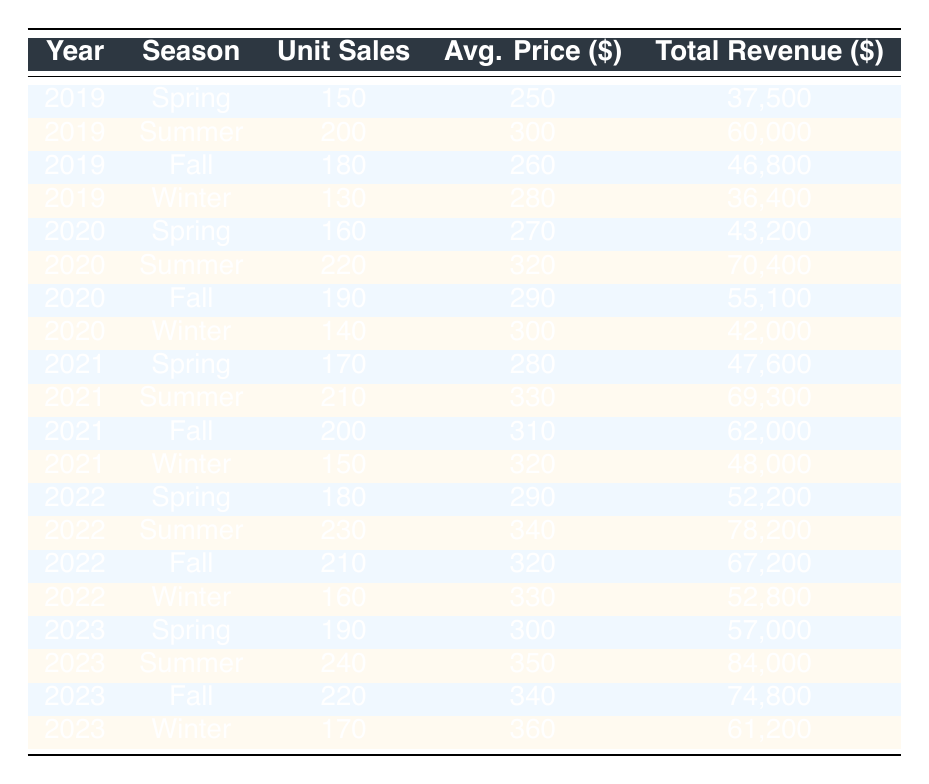What were the total unit sales of telescopes in Summer 2022? The table shows that in Summer 2022, the unit sales were recorded as 230.
Answer: 230 Which season had the highest total revenue in 2023? In 2023, the season with the highest total revenue was Summer, which reported a revenue of 84,000.
Answer: Summer How much did unit sales increase from Spring to Summer in 2021? The unit sales in Spring 2021 were 170 and in Summer 2021 were 210. The increase is calculated as 210 - 170 = 40.
Answer: 40 Did Winter 2022 have higher average prices than Winter 2021? In Winter 2021, the average price was 320, while in Winter 2022, it was 330. Since 330 is greater than 320, the statement is true.
Answer: Yes What is the difference in total revenue between Fall 2020 and Fall 2021? The total revenue for Fall 2020 was 55,100 and for Fall 2021 was 62,000. The difference is calculated as 62,000 - 55,100 = 6,900.
Answer: 6,900 What season in 2019 had the lowest unit sales? A comparison of the unit sales in 2019 shows that Winter had the lowest unit sales of 130 compared to Spring (150), Summer (200), and Fall (180).
Answer: Winter What was the average price across all seasons in 2023? The average prices for the seasons in 2023 were Spring 300, Summer 350, Fall 340, and Winter 360. The total sum is 300 + 350 + 340 + 360 = 1,350, and there are 4 seasons, so the average is 1,350 / 4 = 337.5.
Answer: 337.5 Which year had the highest average price for Summer telescopes? By analyzing the average prices for Summer across the years, in 2019 it was 300, in 2020 it was 320, in 2021 it was 330, in 2022 it was 340, and in 2023 it was 350. The highest average price was in 2023 with 350.
Answer: 2023 How many unit sales were recorded in Winter 2020? The data indicates that the unit sales for Winter 2020 were 140.
Answer: 140 